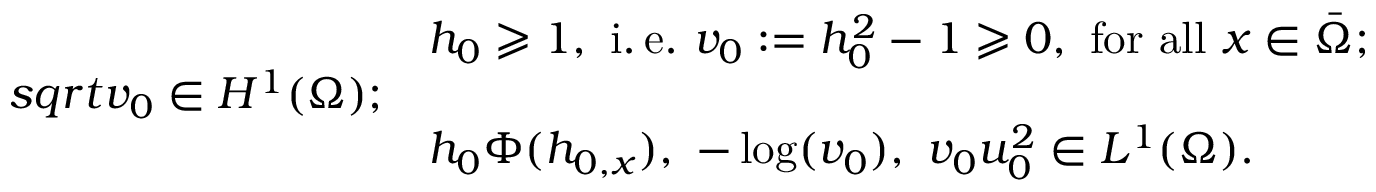<formula> <loc_0><loc_0><loc_500><loc_500>\begin{array} { r l } & { h _ { 0 } \geqslant 1 , i . \, e . v _ { 0 } \colon = h _ { 0 } ^ { 2 } - 1 \geqslant 0 , f o r a l l x \in \bar { \Omega } ; } \\ { s q r t { v _ { 0 } } \in H ^ { 1 } ( \Omega ) ; } \\ & { h _ { 0 } \Phi ( h _ { 0 , x } ) , \ - \log ( v _ { 0 } ) , \ v _ { 0 } u _ { 0 } ^ { 2 } \in L ^ { 1 } ( \Omega ) . } \end{array}</formula> 